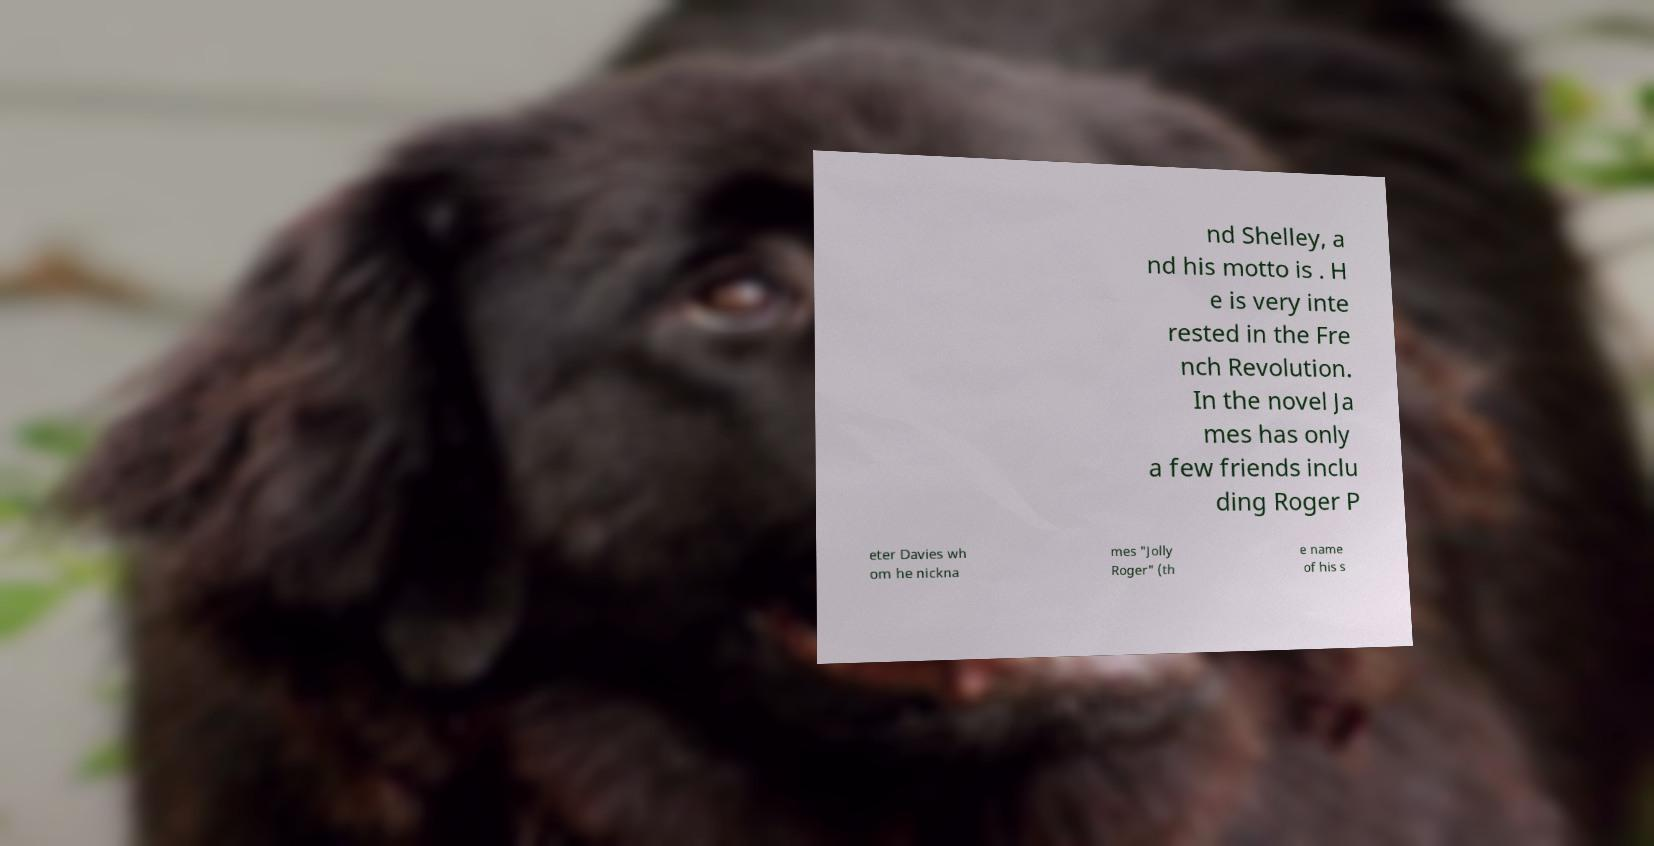Could you assist in decoding the text presented in this image and type it out clearly? nd Shelley, a nd his motto is . H e is very inte rested in the Fre nch Revolution. In the novel Ja mes has only a few friends inclu ding Roger P eter Davies wh om he nickna mes "Jolly Roger" (th e name of his s 